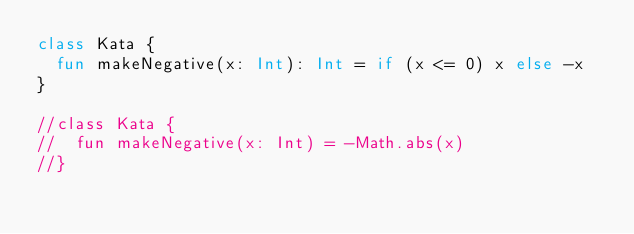Convert code to text. <code><loc_0><loc_0><loc_500><loc_500><_Kotlin_>class Kata {
  fun makeNegative(x: Int): Int = if (x <= 0) x else -x
}

//class Kata {
//  fun makeNegative(x: Int) = -Math.abs(x)
//}
</code> 